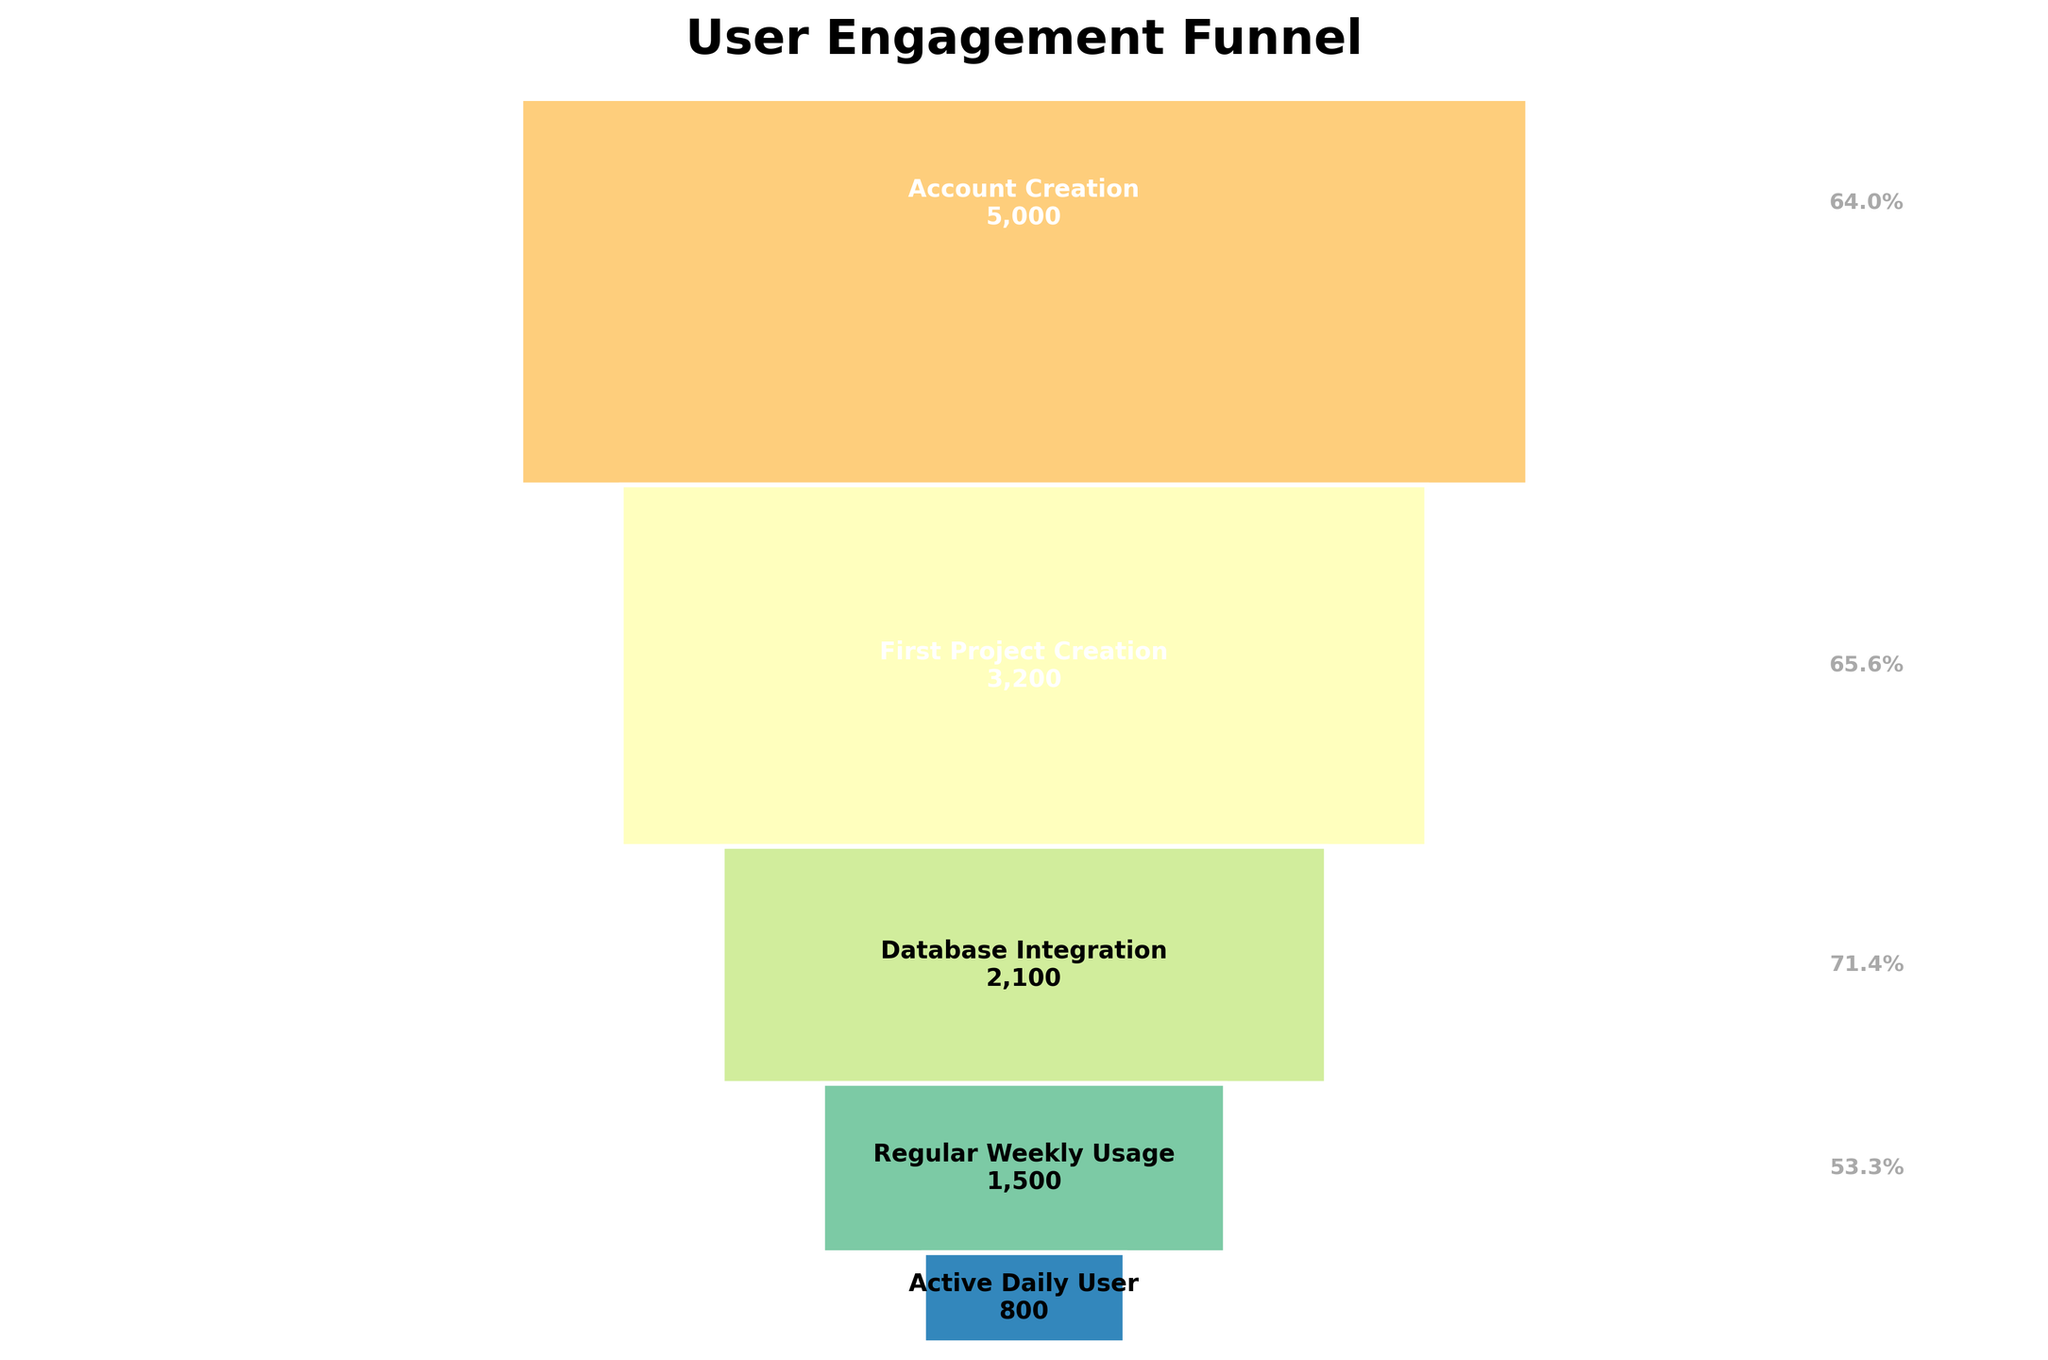What is the title of the funnel chart? The title of a chart is usually found at the top of the figure and gives a summary of what the chart represents. In this case, you can see "User Engagement Funnel" as the title.
Answer: User Engagement Funnel Which stage has the highest number of users? To identify the stage with the highest number of users, look at the first bar of the funnel, which represents the initial point in the funnel. The dataset indicates that the "Initial Website Visit" stage has the highest count of users.
Answer: Initial Website Visit How many users move from 'First Project Creation' to 'Database Integration'? To find the number of users moving from one stage to another, you subtract the users in the latter stage from the former. Hence, 3200 users in 'First Project Creation' minus 2100 users in 'Database Integration' equals 1100 users.
Answer: 1100 What is the percentage drop from 'Sign Up Page View' to 'Account Creation'? Calculate the percentage drop by finding the difference between the users in 'Sign Up Page View' and 'Account Creation', then divide by the initial number and multiply by 100. (7500 - 5000) / 7500 * 100 = 33.33%.
Answer: 33.33% Which stage represents the smallest number of users? The smallest number of users corresponds to the smallest bar segment at the bottom of the funnel. The 'Active Daily User' stage has the lowest count.
Answer: Active Daily User What is the percentage of users who have 'Regular Weekly Usage' relative to those who made 'Account Creation'? To find this, divide the number of users in 'Regular Weekly Usage' by those in 'Account Creation' and multiply by 100. (1500 / 5000) * 100 = 30%.
Answer: 30% How many stages comprise the funnel chart? Count the distinct stages listed in the dataset or visualized in the funnel chart. There are seven stages in total.
Answer: 7 What is the difference in the number of users between the 'Initial Website Visit' and 'Active Daily User'? Subtract the number of users in 'Active Daily User' from those in 'Initial Website Visit': 10000 - 800 = 9200 users.
Answer: 9200 What stage sees a greater than 50% drop in users from the previous stage? Examine the percentage drops annotated on the chart. The drop from 'Sign Up Page View' to 'Account Creation' is less than 50%. But, 'First Project Creation' to 'Database Integration' sees a significant drop; the percentage is (2100 / 3200) * 100 = 65.63%.
Answer: Database Integration Which stage directly follows the 'First Project Creation'? The funnel chart lists stages vertically from top to bottom. The 'Database Integration' follows 'First Project Creation' directly.
Answer: Database Integration 